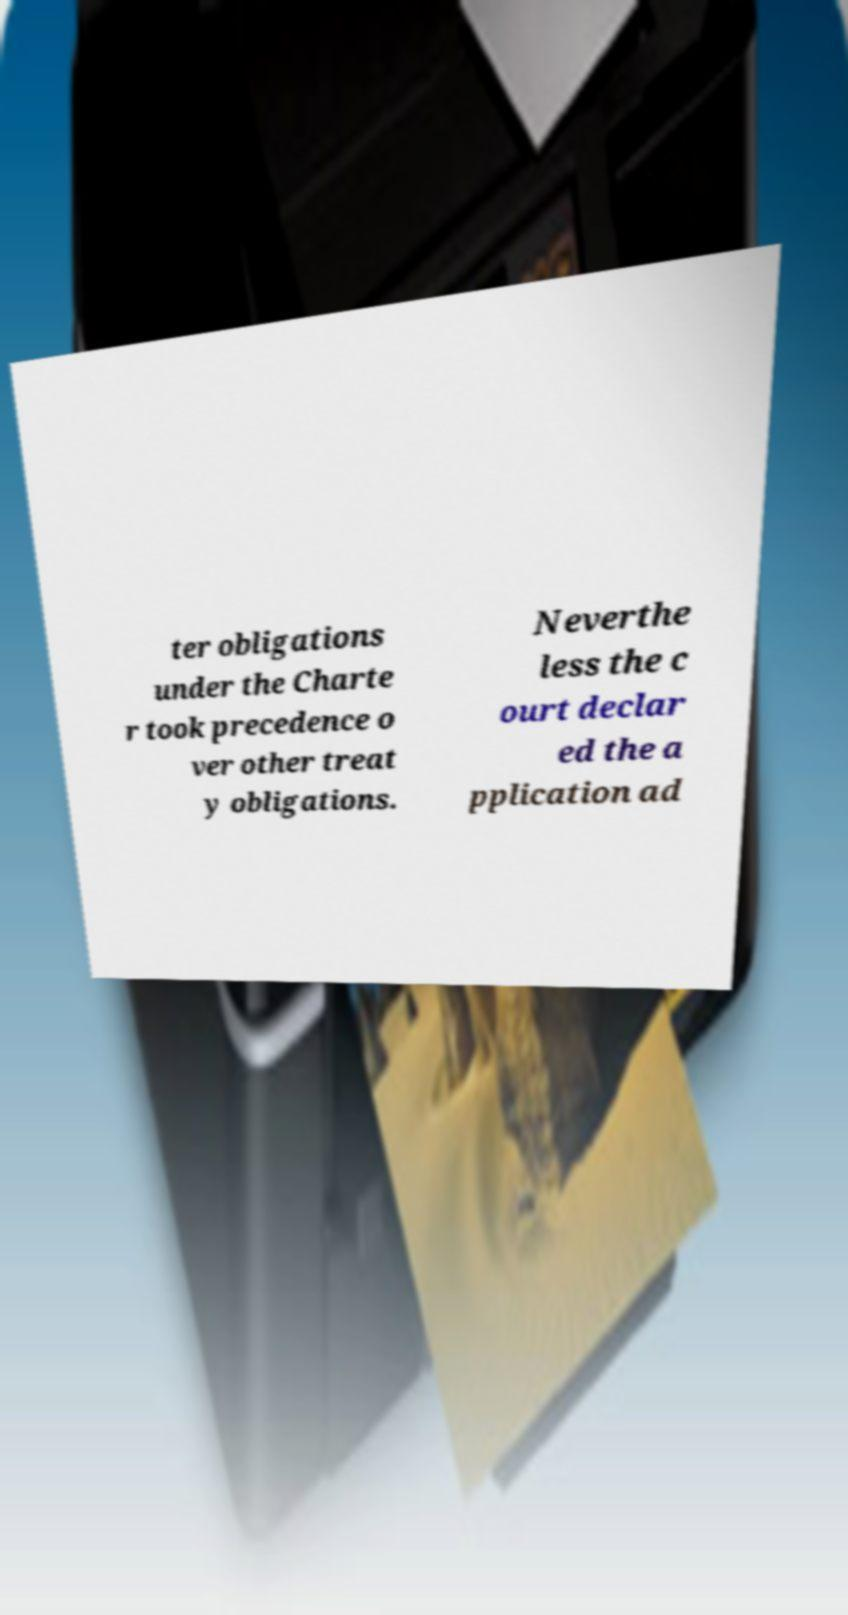Can you read and provide the text displayed in the image?This photo seems to have some interesting text. Can you extract and type it out for me? ter obligations under the Charte r took precedence o ver other treat y obligations. Neverthe less the c ourt declar ed the a pplication ad 